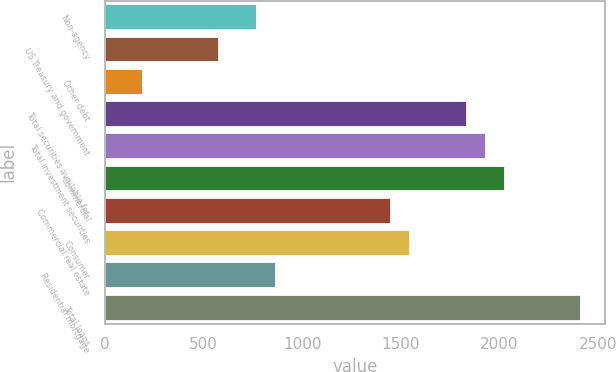Convert chart to OTSL. <chart><loc_0><loc_0><loc_500><loc_500><bar_chart><fcel>Non-agency<fcel>US Treasury and government<fcel>Other debt<fcel>Total securities available for<fcel>Total investment securities<fcel>Commercial<fcel>Commercial real estate<fcel>Consumer<fcel>Residential mortgage<fcel>Total loans<nl><fcel>773.2<fcel>580.4<fcel>194.8<fcel>1833.6<fcel>1930<fcel>2026.4<fcel>1448<fcel>1544.4<fcel>869.6<fcel>2412<nl></chart> 